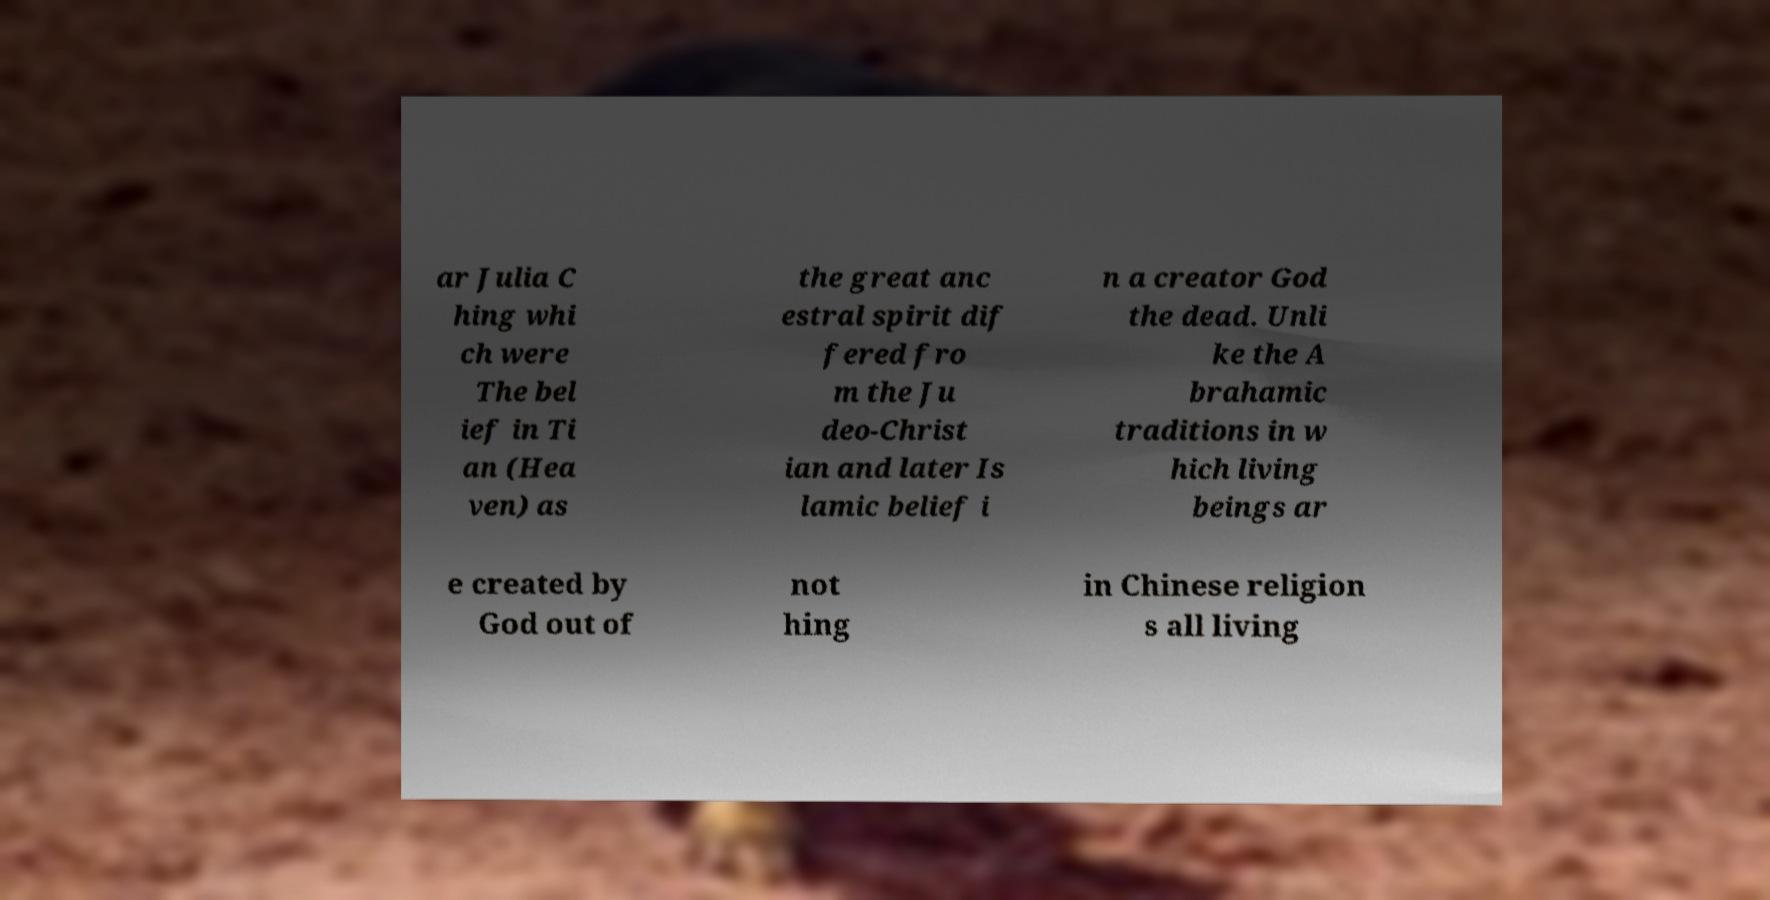I need the written content from this picture converted into text. Can you do that? ar Julia C hing whi ch were The bel ief in Ti an (Hea ven) as the great anc estral spirit dif fered fro m the Ju deo-Christ ian and later Is lamic belief i n a creator God the dead. Unli ke the A brahamic traditions in w hich living beings ar e created by God out of not hing in Chinese religion s all living 